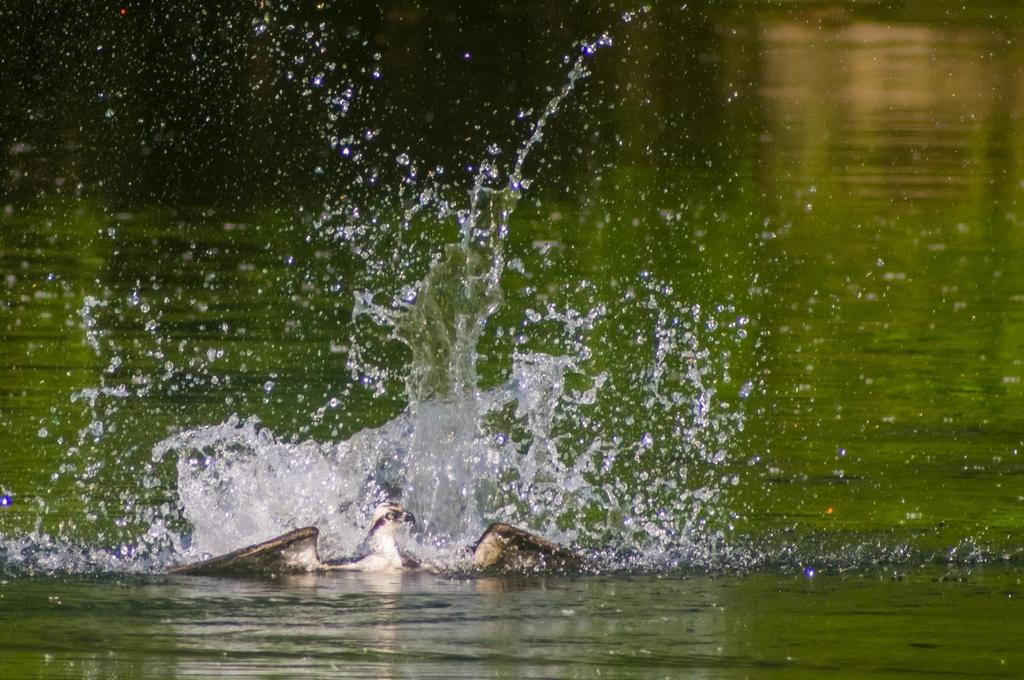What type of animal can be seen in the image? There is a bird in the image. Where is the bird located? The bird is in the water. What colors can be observed on the bird? The bird has white and brown coloring. What is visible in the background of the image? There is a pond in the background of the image. What type of coal is being used by the bird in the image? There is no coal present in the image; it features a bird in the water. How many feet can be seen on the bird in the image? The image does not show the bird's feet, so it cannot be determined from the image. 